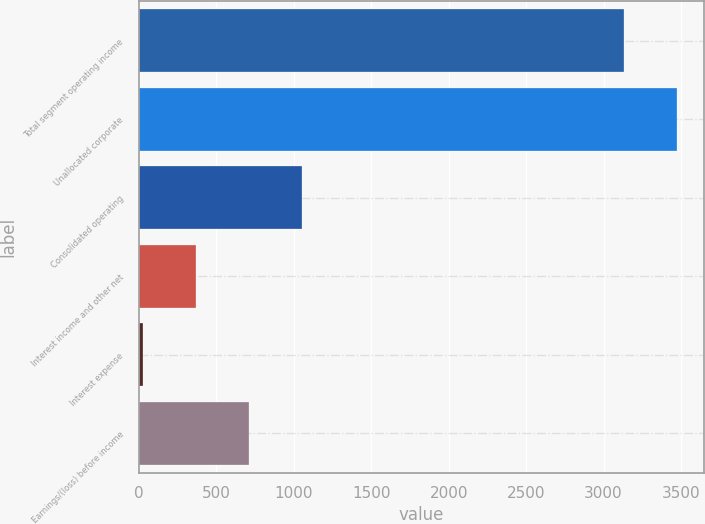Convert chart to OTSL. <chart><loc_0><loc_0><loc_500><loc_500><bar_chart><fcel>Total segment operating income<fcel>Unallocated corporate<fcel>Consolidated operating<fcel>Interest income and other net<fcel>Interest expense<fcel>Earnings/(loss) before income<nl><fcel>3131.6<fcel>3474.49<fcel>1056.77<fcel>370.99<fcel>28.1<fcel>713.88<nl></chart> 